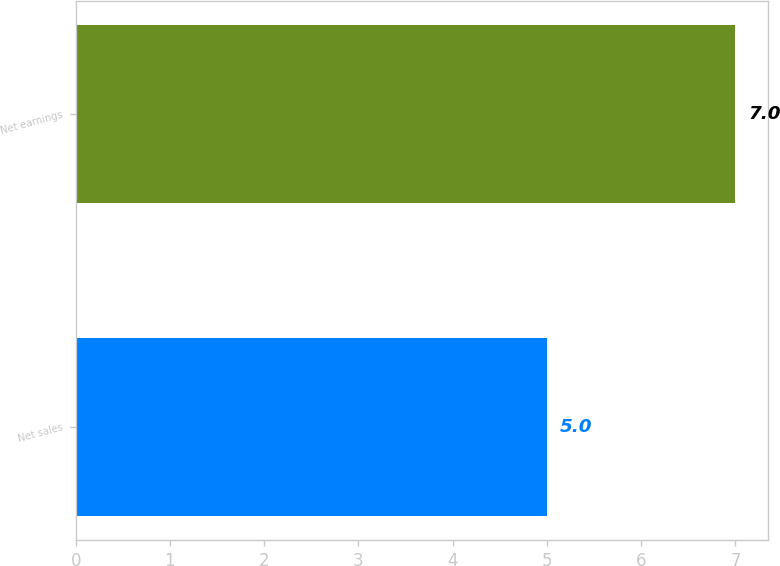Convert chart. <chart><loc_0><loc_0><loc_500><loc_500><bar_chart><fcel>Net sales<fcel>Net earnings<nl><fcel>5<fcel>7<nl></chart> 